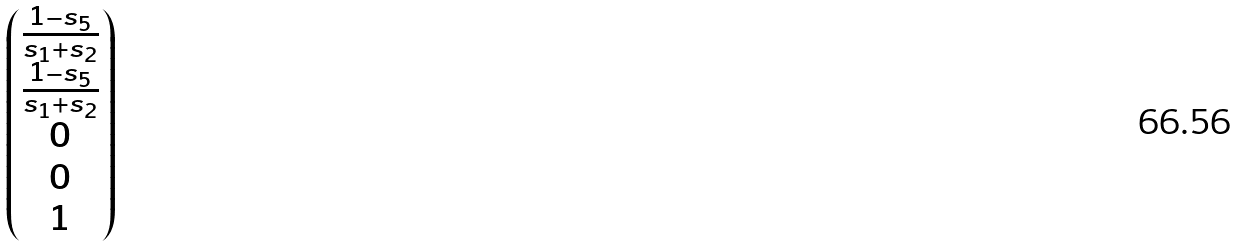Convert formula to latex. <formula><loc_0><loc_0><loc_500><loc_500>\begin{pmatrix} \frac { 1 - s _ { 5 } } { s _ { 1 } + s _ { 2 } } \\ \frac { 1 - s _ { 5 } } { s _ { 1 } + s _ { 2 } } \\ 0 \\ 0 \\ 1 \end{pmatrix}</formula> 